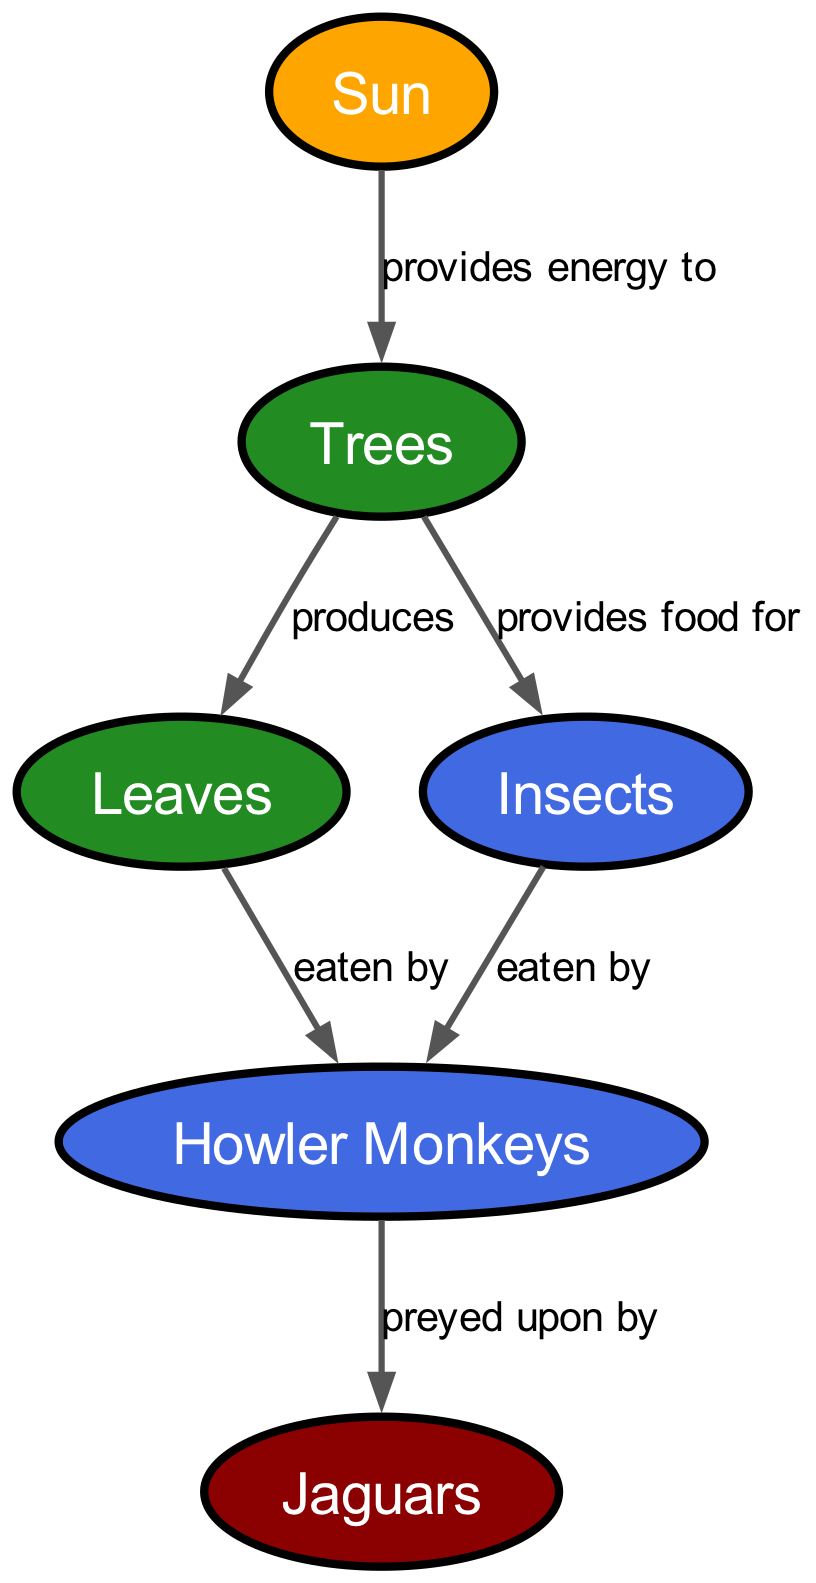What is the energy source in this food chain? The diagram shows that the energy source is the "Sun". The sun is positioned at the top of the food chain, providing energy directly to the trees.
Answer: Sun How many producers are present in the food chain? The diagram lists two producers: "Trees" and "Leaves". By counting the nodes labeled as producers, we find that there are exactly two.
Answer: 2 Which animal is considered the apex predator? The diagram specifically identifies "Jaguars" as the apex predator. It is the last node in the food chain, indicating its top position in the local ecosystem.
Answer: Jaguars What do howler monkeys eat? Looking at the edges connected to "Howler Monkeys", we see they are preyed upon by "Jaguars" and eat both "Leaves" and "Insects". Therefore, their food sources are leaves and insects.
Answer: Leaves, Insects What do trees provide food for in the food chain? The diagram shows that "Trees" provide food for "Insects". The edge labeled accordingly confirms this direct relationship between trees and insects.
Answer: Insects What role do howler monkeys play in this food chain? The diagram describes "Howler Monkeys" as primary consumers. They consume producers like leaves and insects, hence identifying them as primary consumers in the ecosystem.
Answer: Primary consumer How many edges are there in this food chain? The diagram has a total of five edges connecting various nodes. Each edge represents a relationship or flow of energy. By counting each line drawn between the nodes, we confirm there are five.
Answer: 5 What is the relationship between howler monkeys and jaguars? The diagram illustrates that "Howler Monkeys" are "preyed upon by" "Jaguars". This directional edge signifies the predator-prey relationship in the food chain.
Answer: Preyed upon by What do leaves produce in the food chain? According to the diagram, "Leaves" are produced by "Trees". The edge indicates that leaves are a result of the trees' growth process, representing the producer aspect.
Answer: Produced by Trees 